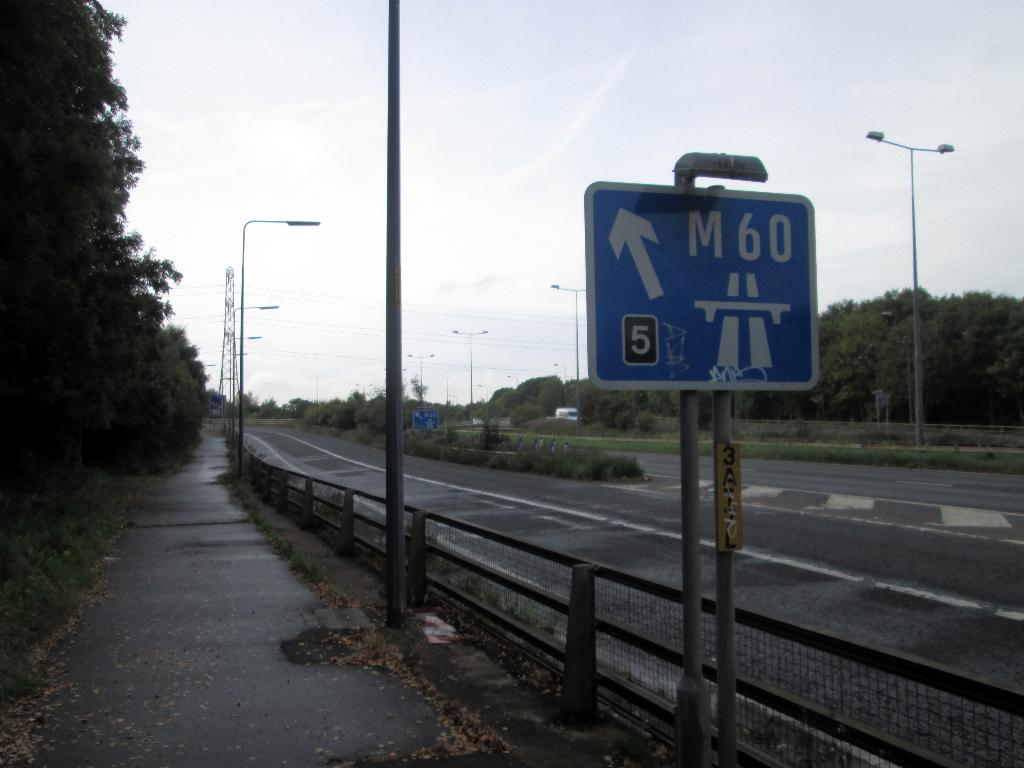<image>
Render a clear and concise summary of the photo. A blue road sign showing that M60 goes to the left. 